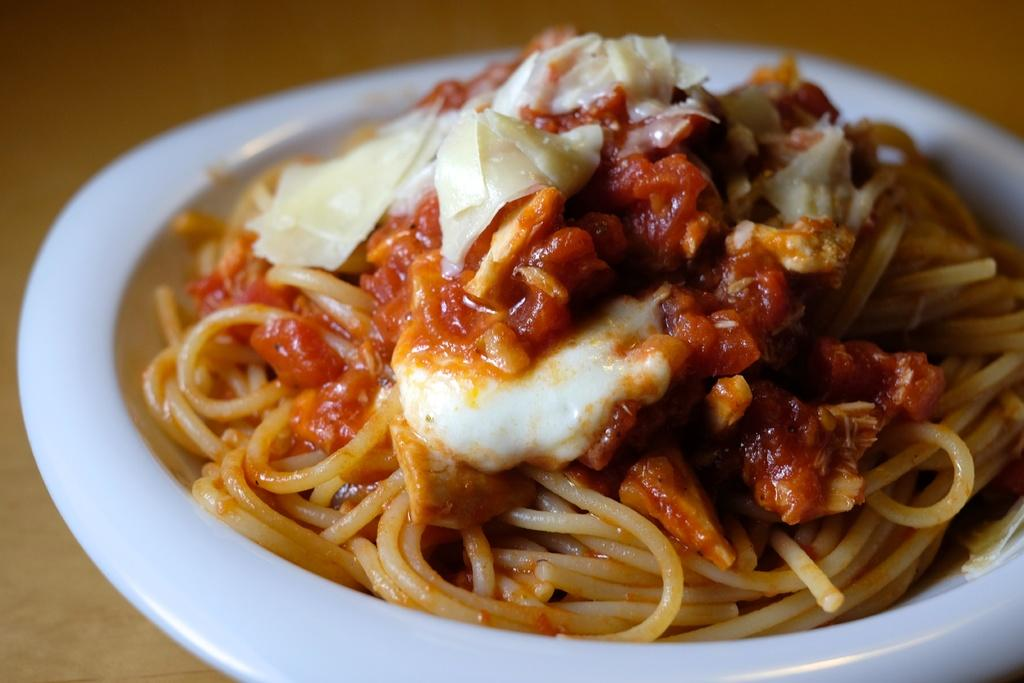What is on the plate in the image? There are food items on a plate. What color is the plate? The plate is white. What is the plate resting on? The plate is on an object. How many ducks are swimming in the food on the plate? There are no ducks present in the image; it features a plate with food items. What impulse might cause someone to eat the food on the plate? The image does not provide information about the person's impulses or motivations for eating the food. 